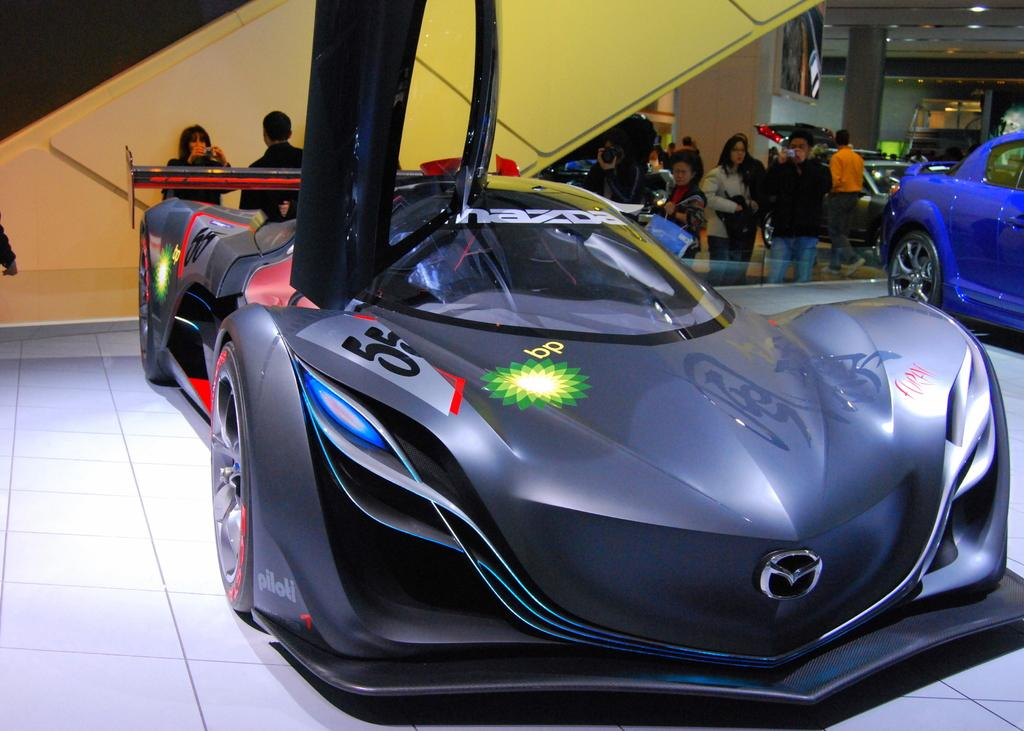What is the main subject in the foreground of the image? There is a car in the foreground of the image. Can you describe the overall scene in the image? There are multiple cars in the image, and people are standing and talking in the background. What type of door can be seen on the car in the image? There is no door visible on the car in the image; only the car itself is shown. 